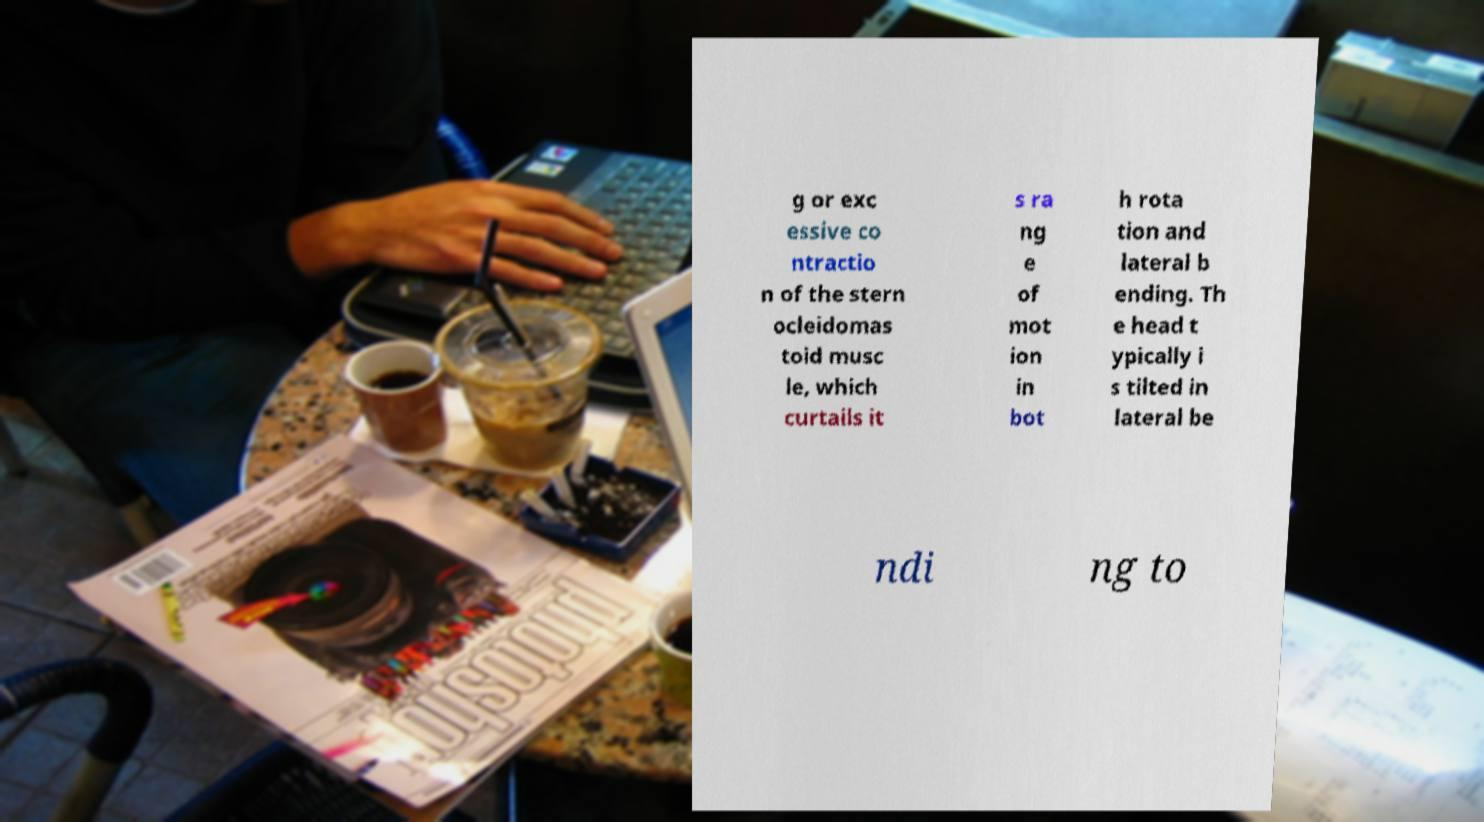What messages or text are displayed in this image? I need them in a readable, typed format. g or exc essive co ntractio n of the stern ocleidomas toid musc le, which curtails it s ra ng e of mot ion in bot h rota tion and lateral b ending. Th e head t ypically i s tilted in lateral be ndi ng to 